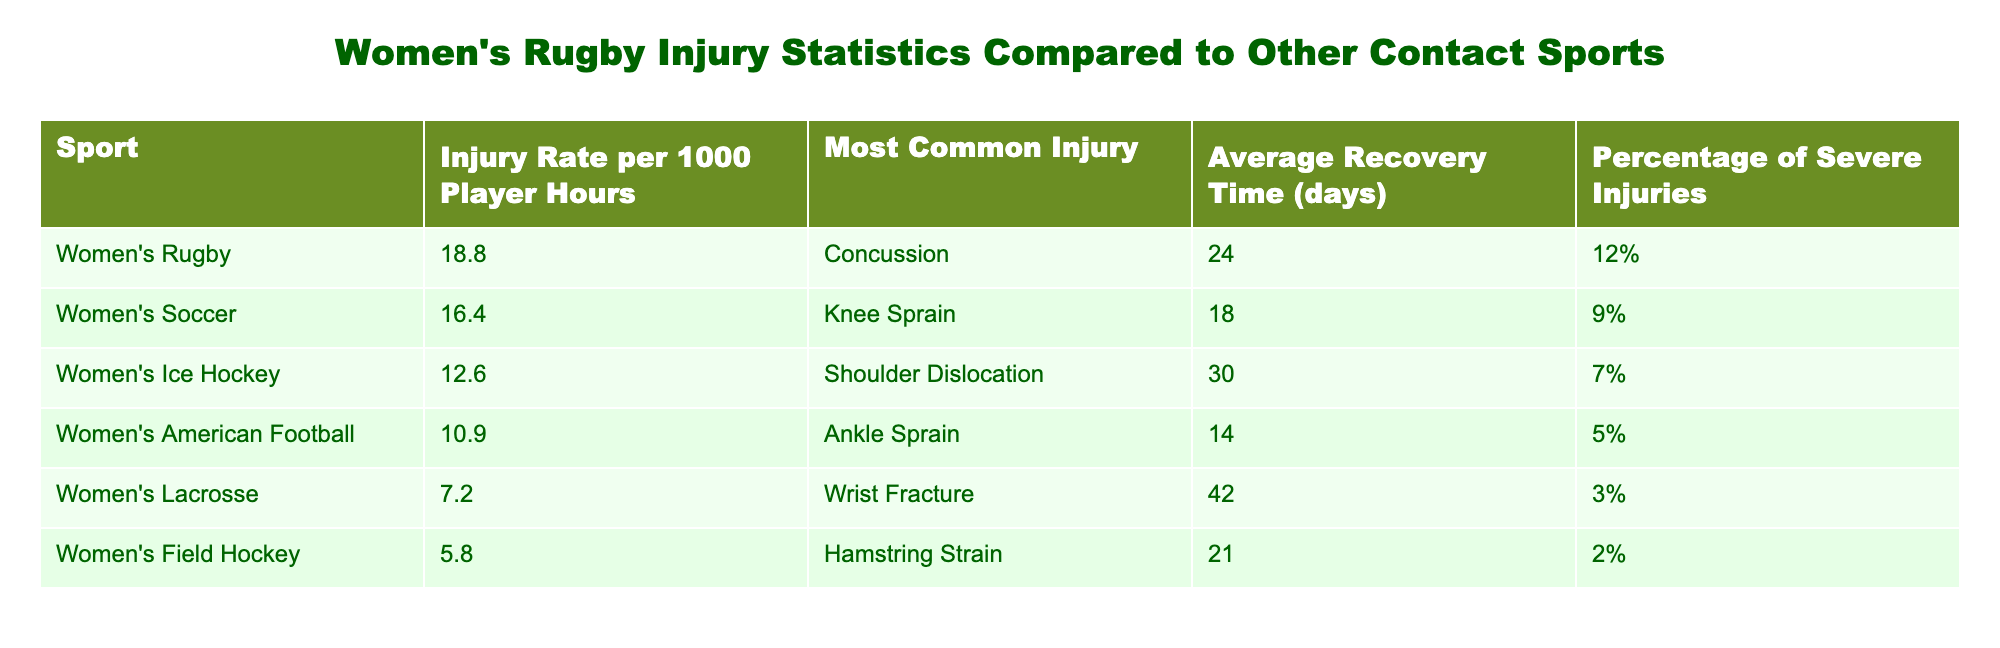What is the injury rate per 1000 player hours for women's rugby? The table lists the injury rate for women's rugby as 18.8 per 1000 player hours.
Answer: 18.8 What is the most common injury among women's ice hockey players? According to the table, the most common injury among women's ice hockey players is shoulder dislocation.
Answer: Shoulder Dislocation Which sport has the highest percentage of severe injuries? By comparing the data, women's rugby has a percentage of severe injuries at 12%, which is higher than the other listed sports.
Answer: Yes What is the average recovery time for knee sprains in women's soccer? The table shows that the average recovery time for knee sprains in women's soccer is 18 days.
Answer: 18 If we consider only sports with a higher injury rate than women's lacrosse, how many sports are there? Women's lacrosse has an injury rate of 7.2, and the sports with higher rates are women's rugby (18.8), women's soccer (16.4), women's ice hockey (12.6), and women's American football (10.9). That totals four sports.
Answer: 4 Is the average recovery time for injuries in women's rugby longer than the average recovery time in women's American football? Women's rugby has an average recovery time of 24 days, while women's American football has an average recovery time of 14 days, which means rugby's recovery time is longer.
Answer: Yes What is the difference in injury rates between women's soccer and women's rugby? The injury rate for women's soccer is 16.4, and for women's rugby it is 18.8. The difference is 18.8 - 16.4 = 2.4.
Answer: 2.4 Which sport has the longest average recovery time and what is it? The longest average recovery time in the table is for women's lacrosse at 42 days, which exceeds all the other sports listed.
Answer: 42 What is the total percentage of severe injuries for women's soccer, women's ice hockey, and women's American football combined? The percentages of severe injuries are: women's soccer 9%, women's ice hockey 7%, and women's American football 5%. When added together, this gives a total of 9 + 7 + 5 = 21%.
Answer: 21% 